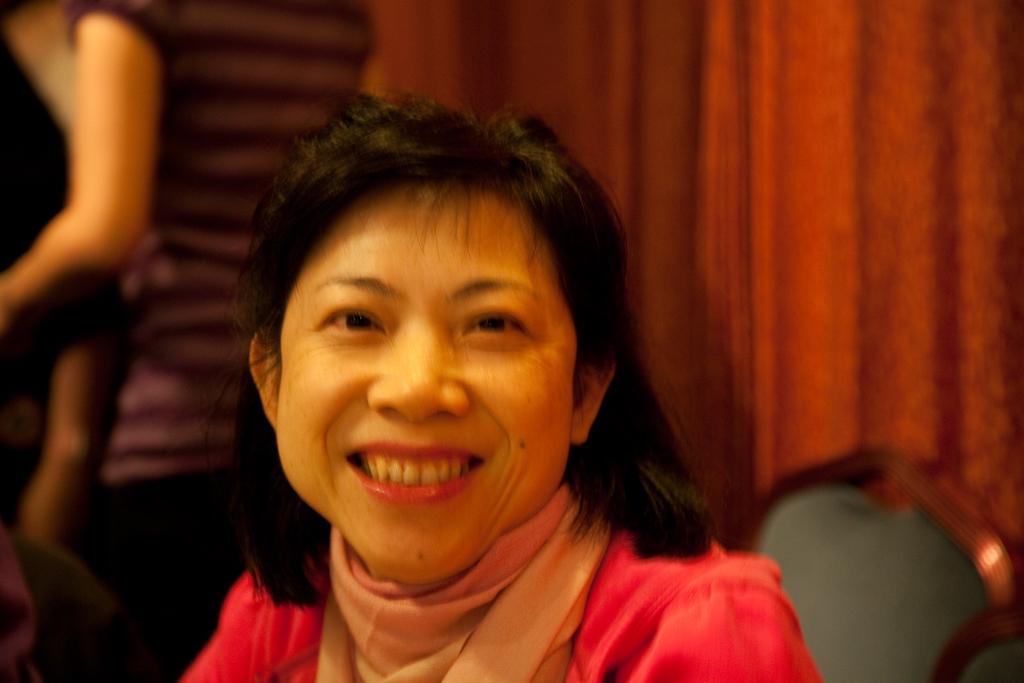Describe this image in one or two sentences. In this image we can see a group of people. In the center of the image we can see a woman sitting on a chair. At the top of the image we can see the curtains. 